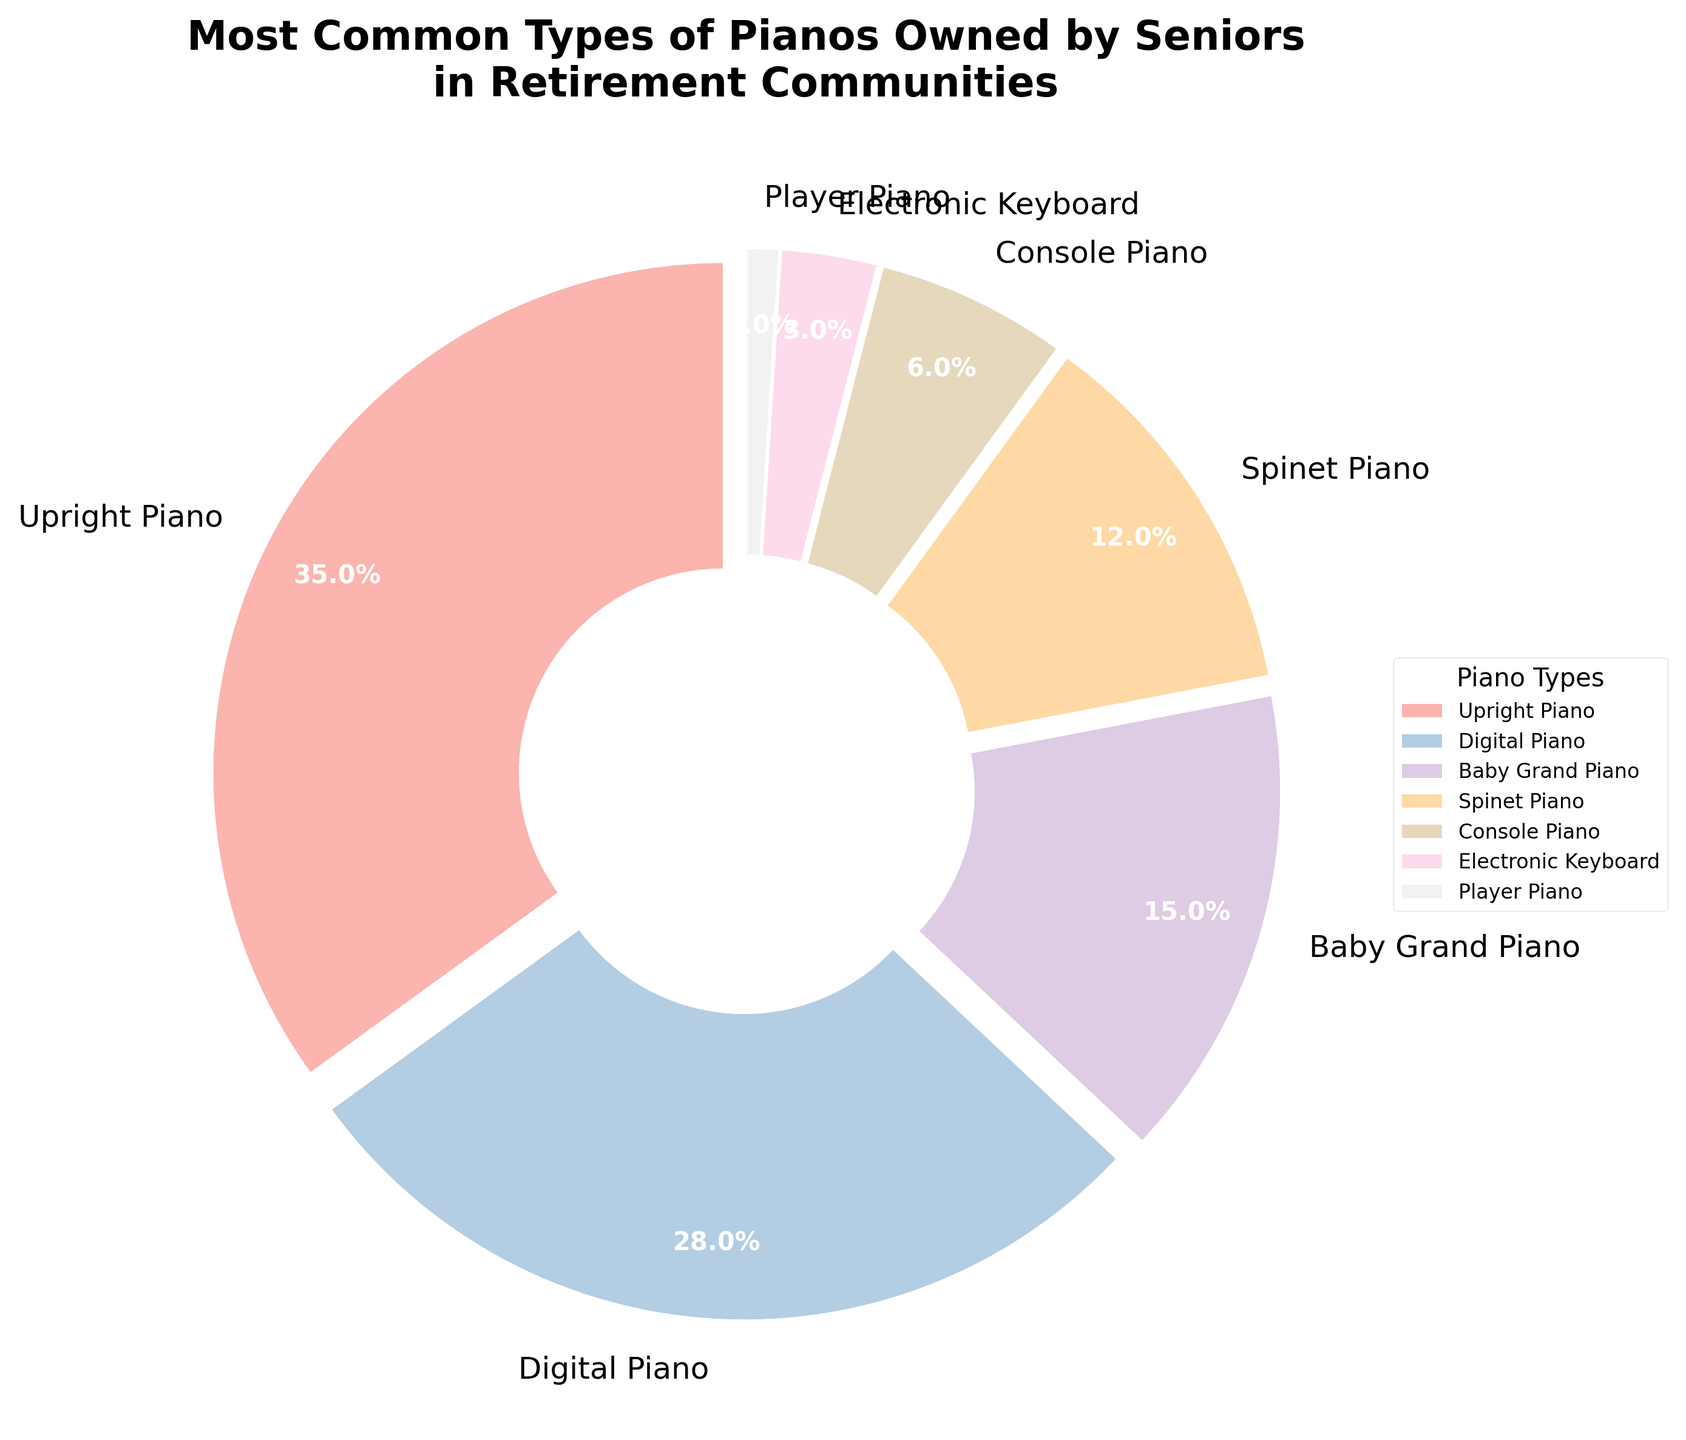Which type of piano is most commonly owned by seniors in retirement communities? The chart shows that the segment with the largest percentage is labeled "Upright Piano", which indicates it is the most commonly owned type.
Answer: Upright Piano What percentage of seniors own digital pianos? The chart shows the percentage for each type of piano. The segment labeled "Digital Piano" represents 28%.
Answer: 28% How many types of pianos are owned by seniors in retirement communities? The chart’s legend lists seven types of pianos.
Answer: 7 What is the combined percentage of seniors who own Baby Grand, Spinet, and Console pianos? The chart shows the percentages for Baby Grand (15%), Spinet (12%), and Console (6%). Adding these together: 15 + 12 + 6 = 33%.
Answer: 33% Which type of piano is less commonly owned than a Spinet Piano but more commonly owned than a Player Piano? The chart shows that less common than Spinet Piano (12%) and more common than Player Piano (1%) is Electronic Keyboard (3%).
Answer: Electronic Keyboard How does the ownership percentage of Upright Pianos compare to that of Digital Pianos? The chart indicates that Upright Pianos account for 35%, while Digital Pianos account for 28%. Comparing the two: 35% is greater than 28%.
Answer: Upright Pianos are 7% more common Are Baby Grand Pianos owned by more or fewer seniors compared to Spinet Pianos? The chart indicates that Baby Grand Pianos and Spinet Pianos are owned by 15% and 12% respectively. Since 15% is more than 12%, Baby Grand Pianos are owned by more seniors.
Answer: More seniors Is the total percentage of ownership for Console and Electronic Keyboard pianos greater than or less than the ownership of Digital Pianos? The chart shows 6% for Console Pianos and 3% for Electronic Keyboards. Summing these: 6 + 3 = 9%, which is less than the 28% for Digital Pianos.
Answer: Less than What is the difference in percentage between the most and least common types of pianos? The most common type is Upright Piano at 35% and the least common is Player Piano at 1%. The difference is 35 - 1 = 34%.
Answer: 34% What colors are used for the slices representing Baby Grand and Player Pianos? The visual attributes in the chart use different pastel colors for each segment. The slice for Baby Grand Piano is a certain pastel shade, while the Player Piano's slice is another distinct pastel shade.
Answer: Pastel shades 